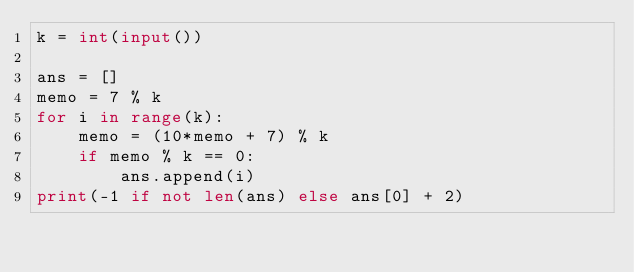Convert code to text. <code><loc_0><loc_0><loc_500><loc_500><_Python_>k = int(input())

ans = []
memo = 7 % k
for i in range(k):
    memo = (10*memo + 7) % k
    if memo % k == 0:
        ans.append(i)
print(-1 if not len(ans) else ans[0] + 2)
</code> 